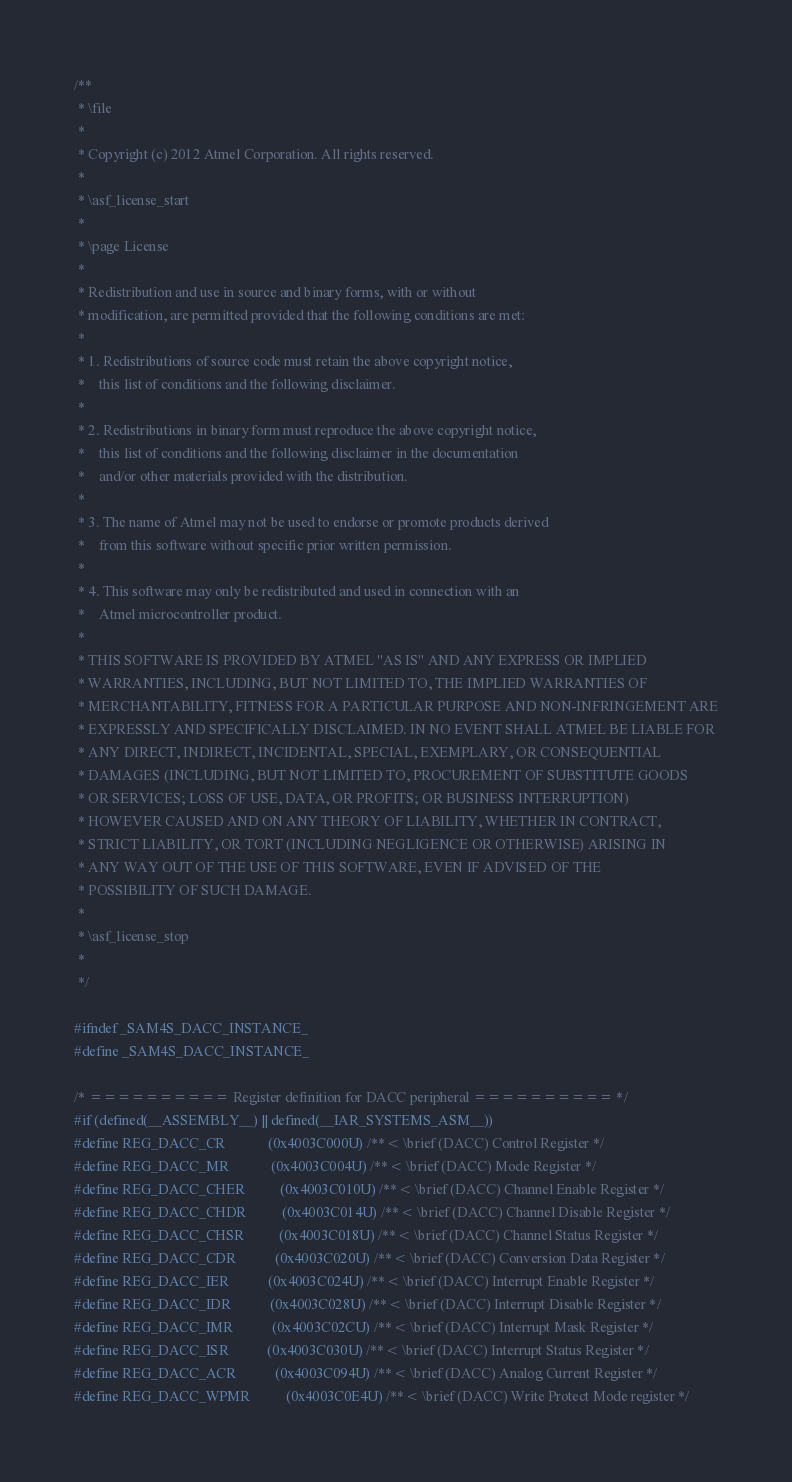Convert code to text. <code><loc_0><loc_0><loc_500><loc_500><_C_>/**
 * \file
 *
 * Copyright (c) 2012 Atmel Corporation. All rights reserved.
 *
 * \asf_license_start
 *
 * \page License
 *
 * Redistribution and use in source and binary forms, with or without
 * modification, are permitted provided that the following conditions are met:
 *
 * 1. Redistributions of source code must retain the above copyright notice,
 *    this list of conditions and the following disclaimer.
 *
 * 2. Redistributions in binary form must reproduce the above copyright notice,
 *    this list of conditions and the following disclaimer in the documentation
 *    and/or other materials provided with the distribution.
 *
 * 3. The name of Atmel may not be used to endorse or promote products derived
 *    from this software without specific prior written permission.
 *
 * 4. This software may only be redistributed and used in connection with an
 *    Atmel microcontroller product.
 *
 * THIS SOFTWARE IS PROVIDED BY ATMEL "AS IS" AND ANY EXPRESS OR IMPLIED
 * WARRANTIES, INCLUDING, BUT NOT LIMITED TO, THE IMPLIED WARRANTIES OF
 * MERCHANTABILITY, FITNESS FOR A PARTICULAR PURPOSE AND NON-INFRINGEMENT ARE
 * EXPRESSLY AND SPECIFICALLY DISCLAIMED. IN NO EVENT SHALL ATMEL BE LIABLE FOR
 * ANY DIRECT, INDIRECT, INCIDENTAL, SPECIAL, EXEMPLARY, OR CONSEQUENTIAL
 * DAMAGES (INCLUDING, BUT NOT LIMITED TO, PROCUREMENT OF SUBSTITUTE GOODS
 * OR SERVICES; LOSS OF USE, DATA, OR PROFITS; OR BUSINESS INTERRUPTION)
 * HOWEVER CAUSED AND ON ANY THEORY OF LIABILITY, WHETHER IN CONTRACT,
 * STRICT LIABILITY, OR TORT (INCLUDING NEGLIGENCE OR OTHERWISE) ARISING IN
 * ANY WAY OUT OF THE USE OF THIS SOFTWARE, EVEN IF ADVISED OF THE
 * POSSIBILITY OF SUCH DAMAGE.
 *
 * \asf_license_stop
 *
 */

#ifndef _SAM4S_DACC_INSTANCE_
#define _SAM4S_DACC_INSTANCE_

/* ========== Register definition for DACC peripheral ========== */
#if (defined(__ASSEMBLY__) || defined(__IAR_SYSTEMS_ASM__))
#define REG_DACC_CR            (0x4003C000U) /**< \brief (DACC) Control Register */
#define REG_DACC_MR            (0x4003C004U) /**< \brief (DACC) Mode Register */
#define REG_DACC_CHER          (0x4003C010U) /**< \brief (DACC) Channel Enable Register */
#define REG_DACC_CHDR          (0x4003C014U) /**< \brief (DACC) Channel Disable Register */
#define REG_DACC_CHSR          (0x4003C018U) /**< \brief (DACC) Channel Status Register */
#define REG_DACC_CDR           (0x4003C020U) /**< \brief (DACC) Conversion Data Register */
#define REG_DACC_IER           (0x4003C024U) /**< \brief (DACC) Interrupt Enable Register */
#define REG_DACC_IDR           (0x4003C028U) /**< \brief (DACC) Interrupt Disable Register */
#define REG_DACC_IMR           (0x4003C02CU) /**< \brief (DACC) Interrupt Mask Register */
#define REG_DACC_ISR           (0x4003C030U) /**< \brief (DACC) Interrupt Status Register */
#define REG_DACC_ACR           (0x4003C094U) /**< \brief (DACC) Analog Current Register */
#define REG_DACC_WPMR          (0x4003C0E4U) /**< \brief (DACC) Write Protect Mode register */</code> 